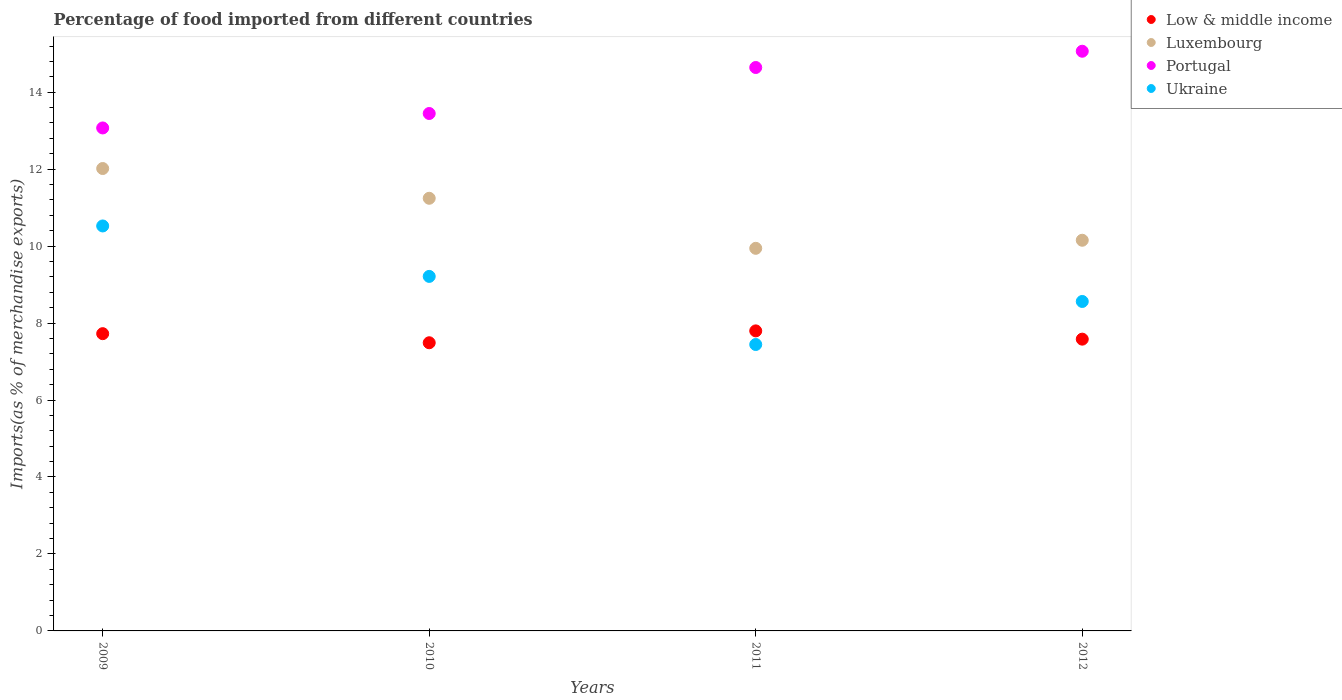How many different coloured dotlines are there?
Offer a very short reply. 4. Is the number of dotlines equal to the number of legend labels?
Ensure brevity in your answer.  Yes. What is the percentage of imports to different countries in Low & middle income in 2009?
Make the answer very short. 7.72. Across all years, what is the maximum percentage of imports to different countries in Ukraine?
Your answer should be very brief. 10.52. Across all years, what is the minimum percentage of imports to different countries in Low & middle income?
Give a very brief answer. 7.49. In which year was the percentage of imports to different countries in Ukraine maximum?
Your answer should be compact. 2009. In which year was the percentage of imports to different countries in Low & middle income minimum?
Make the answer very short. 2010. What is the total percentage of imports to different countries in Low & middle income in the graph?
Offer a very short reply. 30.59. What is the difference between the percentage of imports to different countries in Low & middle income in 2011 and that in 2012?
Keep it short and to the point. 0.21. What is the difference between the percentage of imports to different countries in Ukraine in 2009 and the percentage of imports to different countries in Portugal in 2012?
Provide a succinct answer. -4.54. What is the average percentage of imports to different countries in Ukraine per year?
Provide a short and direct response. 8.94. In the year 2011, what is the difference between the percentage of imports to different countries in Ukraine and percentage of imports to different countries in Portugal?
Offer a terse response. -7.2. In how many years, is the percentage of imports to different countries in Low & middle income greater than 14.4 %?
Your answer should be very brief. 0. What is the ratio of the percentage of imports to different countries in Luxembourg in 2010 to that in 2011?
Keep it short and to the point. 1.13. Is the percentage of imports to different countries in Ukraine in 2010 less than that in 2012?
Make the answer very short. No. Is the difference between the percentage of imports to different countries in Ukraine in 2009 and 2012 greater than the difference between the percentage of imports to different countries in Portugal in 2009 and 2012?
Provide a short and direct response. Yes. What is the difference between the highest and the second highest percentage of imports to different countries in Ukraine?
Your answer should be compact. 1.31. What is the difference between the highest and the lowest percentage of imports to different countries in Portugal?
Provide a succinct answer. 1.99. In how many years, is the percentage of imports to different countries in Portugal greater than the average percentage of imports to different countries in Portugal taken over all years?
Your answer should be very brief. 2. Is the sum of the percentage of imports to different countries in Ukraine in 2009 and 2011 greater than the maximum percentage of imports to different countries in Portugal across all years?
Offer a very short reply. Yes. Is it the case that in every year, the sum of the percentage of imports to different countries in Luxembourg and percentage of imports to different countries in Portugal  is greater than the sum of percentage of imports to different countries in Ukraine and percentage of imports to different countries in Low & middle income?
Your response must be concise. No. Is the percentage of imports to different countries in Low & middle income strictly less than the percentage of imports to different countries in Portugal over the years?
Your response must be concise. Yes. How many dotlines are there?
Offer a very short reply. 4. How many legend labels are there?
Provide a short and direct response. 4. What is the title of the graph?
Your answer should be compact. Percentage of food imported from different countries. Does "Belgium" appear as one of the legend labels in the graph?
Your response must be concise. No. What is the label or title of the X-axis?
Provide a succinct answer. Years. What is the label or title of the Y-axis?
Offer a very short reply. Imports(as % of merchandise exports). What is the Imports(as % of merchandise exports) of Low & middle income in 2009?
Provide a short and direct response. 7.72. What is the Imports(as % of merchandise exports) in Luxembourg in 2009?
Ensure brevity in your answer.  12.02. What is the Imports(as % of merchandise exports) of Portugal in 2009?
Offer a terse response. 13.07. What is the Imports(as % of merchandise exports) of Ukraine in 2009?
Ensure brevity in your answer.  10.52. What is the Imports(as % of merchandise exports) of Low & middle income in 2010?
Keep it short and to the point. 7.49. What is the Imports(as % of merchandise exports) of Luxembourg in 2010?
Offer a terse response. 11.24. What is the Imports(as % of merchandise exports) in Portugal in 2010?
Your answer should be compact. 13.45. What is the Imports(as % of merchandise exports) of Ukraine in 2010?
Your answer should be compact. 9.21. What is the Imports(as % of merchandise exports) of Low & middle income in 2011?
Your answer should be very brief. 7.8. What is the Imports(as % of merchandise exports) in Luxembourg in 2011?
Your answer should be very brief. 9.94. What is the Imports(as % of merchandise exports) of Portugal in 2011?
Give a very brief answer. 14.64. What is the Imports(as % of merchandise exports) in Ukraine in 2011?
Offer a very short reply. 7.44. What is the Imports(as % of merchandise exports) in Low & middle income in 2012?
Make the answer very short. 7.58. What is the Imports(as % of merchandise exports) of Luxembourg in 2012?
Your answer should be compact. 10.15. What is the Imports(as % of merchandise exports) in Portugal in 2012?
Your response must be concise. 15.06. What is the Imports(as % of merchandise exports) of Ukraine in 2012?
Offer a very short reply. 8.56. Across all years, what is the maximum Imports(as % of merchandise exports) of Low & middle income?
Your answer should be very brief. 7.8. Across all years, what is the maximum Imports(as % of merchandise exports) of Luxembourg?
Ensure brevity in your answer.  12.02. Across all years, what is the maximum Imports(as % of merchandise exports) in Portugal?
Your answer should be very brief. 15.06. Across all years, what is the maximum Imports(as % of merchandise exports) in Ukraine?
Ensure brevity in your answer.  10.52. Across all years, what is the minimum Imports(as % of merchandise exports) in Low & middle income?
Provide a succinct answer. 7.49. Across all years, what is the minimum Imports(as % of merchandise exports) of Luxembourg?
Provide a succinct answer. 9.94. Across all years, what is the minimum Imports(as % of merchandise exports) in Portugal?
Keep it short and to the point. 13.07. Across all years, what is the minimum Imports(as % of merchandise exports) of Ukraine?
Your answer should be very brief. 7.44. What is the total Imports(as % of merchandise exports) of Low & middle income in the graph?
Your answer should be very brief. 30.59. What is the total Imports(as % of merchandise exports) in Luxembourg in the graph?
Ensure brevity in your answer.  43.35. What is the total Imports(as % of merchandise exports) in Portugal in the graph?
Your response must be concise. 56.22. What is the total Imports(as % of merchandise exports) in Ukraine in the graph?
Your answer should be very brief. 35.74. What is the difference between the Imports(as % of merchandise exports) of Low & middle income in 2009 and that in 2010?
Provide a short and direct response. 0.24. What is the difference between the Imports(as % of merchandise exports) in Luxembourg in 2009 and that in 2010?
Keep it short and to the point. 0.77. What is the difference between the Imports(as % of merchandise exports) of Portugal in 2009 and that in 2010?
Keep it short and to the point. -0.38. What is the difference between the Imports(as % of merchandise exports) in Ukraine in 2009 and that in 2010?
Your answer should be very brief. 1.31. What is the difference between the Imports(as % of merchandise exports) in Low & middle income in 2009 and that in 2011?
Offer a very short reply. -0.07. What is the difference between the Imports(as % of merchandise exports) of Luxembourg in 2009 and that in 2011?
Make the answer very short. 2.07. What is the difference between the Imports(as % of merchandise exports) of Portugal in 2009 and that in 2011?
Make the answer very short. -1.57. What is the difference between the Imports(as % of merchandise exports) of Ukraine in 2009 and that in 2011?
Your answer should be compact. 3.08. What is the difference between the Imports(as % of merchandise exports) in Low & middle income in 2009 and that in 2012?
Your answer should be very brief. 0.14. What is the difference between the Imports(as % of merchandise exports) of Luxembourg in 2009 and that in 2012?
Provide a succinct answer. 1.86. What is the difference between the Imports(as % of merchandise exports) of Portugal in 2009 and that in 2012?
Your answer should be compact. -1.99. What is the difference between the Imports(as % of merchandise exports) in Ukraine in 2009 and that in 2012?
Your answer should be compact. 1.96. What is the difference between the Imports(as % of merchandise exports) of Low & middle income in 2010 and that in 2011?
Make the answer very short. -0.31. What is the difference between the Imports(as % of merchandise exports) of Luxembourg in 2010 and that in 2011?
Provide a succinct answer. 1.3. What is the difference between the Imports(as % of merchandise exports) in Portugal in 2010 and that in 2011?
Make the answer very short. -1.2. What is the difference between the Imports(as % of merchandise exports) of Ukraine in 2010 and that in 2011?
Your answer should be very brief. 1.77. What is the difference between the Imports(as % of merchandise exports) of Low & middle income in 2010 and that in 2012?
Your answer should be very brief. -0.09. What is the difference between the Imports(as % of merchandise exports) of Luxembourg in 2010 and that in 2012?
Keep it short and to the point. 1.09. What is the difference between the Imports(as % of merchandise exports) of Portugal in 2010 and that in 2012?
Keep it short and to the point. -1.62. What is the difference between the Imports(as % of merchandise exports) in Ukraine in 2010 and that in 2012?
Offer a very short reply. 0.65. What is the difference between the Imports(as % of merchandise exports) in Low & middle income in 2011 and that in 2012?
Provide a succinct answer. 0.21. What is the difference between the Imports(as % of merchandise exports) of Luxembourg in 2011 and that in 2012?
Your answer should be compact. -0.21. What is the difference between the Imports(as % of merchandise exports) of Portugal in 2011 and that in 2012?
Provide a short and direct response. -0.42. What is the difference between the Imports(as % of merchandise exports) in Ukraine in 2011 and that in 2012?
Your response must be concise. -1.12. What is the difference between the Imports(as % of merchandise exports) of Low & middle income in 2009 and the Imports(as % of merchandise exports) of Luxembourg in 2010?
Offer a very short reply. -3.52. What is the difference between the Imports(as % of merchandise exports) of Low & middle income in 2009 and the Imports(as % of merchandise exports) of Portugal in 2010?
Provide a short and direct response. -5.72. What is the difference between the Imports(as % of merchandise exports) of Low & middle income in 2009 and the Imports(as % of merchandise exports) of Ukraine in 2010?
Provide a succinct answer. -1.49. What is the difference between the Imports(as % of merchandise exports) in Luxembourg in 2009 and the Imports(as % of merchandise exports) in Portugal in 2010?
Give a very brief answer. -1.43. What is the difference between the Imports(as % of merchandise exports) of Luxembourg in 2009 and the Imports(as % of merchandise exports) of Ukraine in 2010?
Give a very brief answer. 2.8. What is the difference between the Imports(as % of merchandise exports) of Portugal in 2009 and the Imports(as % of merchandise exports) of Ukraine in 2010?
Your answer should be compact. 3.86. What is the difference between the Imports(as % of merchandise exports) in Low & middle income in 2009 and the Imports(as % of merchandise exports) in Luxembourg in 2011?
Give a very brief answer. -2.22. What is the difference between the Imports(as % of merchandise exports) in Low & middle income in 2009 and the Imports(as % of merchandise exports) in Portugal in 2011?
Make the answer very short. -6.92. What is the difference between the Imports(as % of merchandise exports) of Low & middle income in 2009 and the Imports(as % of merchandise exports) of Ukraine in 2011?
Provide a short and direct response. 0.28. What is the difference between the Imports(as % of merchandise exports) in Luxembourg in 2009 and the Imports(as % of merchandise exports) in Portugal in 2011?
Keep it short and to the point. -2.63. What is the difference between the Imports(as % of merchandise exports) of Luxembourg in 2009 and the Imports(as % of merchandise exports) of Ukraine in 2011?
Offer a very short reply. 4.57. What is the difference between the Imports(as % of merchandise exports) of Portugal in 2009 and the Imports(as % of merchandise exports) of Ukraine in 2011?
Your answer should be compact. 5.63. What is the difference between the Imports(as % of merchandise exports) in Low & middle income in 2009 and the Imports(as % of merchandise exports) in Luxembourg in 2012?
Ensure brevity in your answer.  -2.43. What is the difference between the Imports(as % of merchandise exports) in Low & middle income in 2009 and the Imports(as % of merchandise exports) in Portugal in 2012?
Keep it short and to the point. -7.34. What is the difference between the Imports(as % of merchandise exports) in Low & middle income in 2009 and the Imports(as % of merchandise exports) in Ukraine in 2012?
Offer a terse response. -0.84. What is the difference between the Imports(as % of merchandise exports) in Luxembourg in 2009 and the Imports(as % of merchandise exports) in Portugal in 2012?
Offer a very short reply. -3.05. What is the difference between the Imports(as % of merchandise exports) of Luxembourg in 2009 and the Imports(as % of merchandise exports) of Ukraine in 2012?
Your response must be concise. 3.45. What is the difference between the Imports(as % of merchandise exports) in Portugal in 2009 and the Imports(as % of merchandise exports) in Ukraine in 2012?
Keep it short and to the point. 4.51. What is the difference between the Imports(as % of merchandise exports) in Low & middle income in 2010 and the Imports(as % of merchandise exports) in Luxembourg in 2011?
Offer a terse response. -2.45. What is the difference between the Imports(as % of merchandise exports) in Low & middle income in 2010 and the Imports(as % of merchandise exports) in Portugal in 2011?
Provide a succinct answer. -7.15. What is the difference between the Imports(as % of merchandise exports) of Low & middle income in 2010 and the Imports(as % of merchandise exports) of Ukraine in 2011?
Give a very brief answer. 0.05. What is the difference between the Imports(as % of merchandise exports) of Luxembourg in 2010 and the Imports(as % of merchandise exports) of Portugal in 2011?
Keep it short and to the point. -3.4. What is the difference between the Imports(as % of merchandise exports) of Luxembourg in 2010 and the Imports(as % of merchandise exports) of Ukraine in 2011?
Provide a succinct answer. 3.8. What is the difference between the Imports(as % of merchandise exports) in Portugal in 2010 and the Imports(as % of merchandise exports) in Ukraine in 2011?
Keep it short and to the point. 6. What is the difference between the Imports(as % of merchandise exports) in Low & middle income in 2010 and the Imports(as % of merchandise exports) in Luxembourg in 2012?
Ensure brevity in your answer.  -2.66. What is the difference between the Imports(as % of merchandise exports) of Low & middle income in 2010 and the Imports(as % of merchandise exports) of Portugal in 2012?
Offer a very short reply. -7.58. What is the difference between the Imports(as % of merchandise exports) in Low & middle income in 2010 and the Imports(as % of merchandise exports) in Ukraine in 2012?
Give a very brief answer. -1.07. What is the difference between the Imports(as % of merchandise exports) in Luxembourg in 2010 and the Imports(as % of merchandise exports) in Portugal in 2012?
Your answer should be compact. -3.82. What is the difference between the Imports(as % of merchandise exports) of Luxembourg in 2010 and the Imports(as % of merchandise exports) of Ukraine in 2012?
Your answer should be compact. 2.68. What is the difference between the Imports(as % of merchandise exports) of Portugal in 2010 and the Imports(as % of merchandise exports) of Ukraine in 2012?
Provide a short and direct response. 4.88. What is the difference between the Imports(as % of merchandise exports) in Low & middle income in 2011 and the Imports(as % of merchandise exports) in Luxembourg in 2012?
Provide a succinct answer. -2.36. What is the difference between the Imports(as % of merchandise exports) in Low & middle income in 2011 and the Imports(as % of merchandise exports) in Portugal in 2012?
Provide a short and direct response. -7.27. What is the difference between the Imports(as % of merchandise exports) of Low & middle income in 2011 and the Imports(as % of merchandise exports) of Ukraine in 2012?
Provide a succinct answer. -0.76. What is the difference between the Imports(as % of merchandise exports) of Luxembourg in 2011 and the Imports(as % of merchandise exports) of Portugal in 2012?
Your answer should be compact. -5.12. What is the difference between the Imports(as % of merchandise exports) of Luxembourg in 2011 and the Imports(as % of merchandise exports) of Ukraine in 2012?
Keep it short and to the point. 1.38. What is the difference between the Imports(as % of merchandise exports) of Portugal in 2011 and the Imports(as % of merchandise exports) of Ukraine in 2012?
Keep it short and to the point. 6.08. What is the average Imports(as % of merchandise exports) of Low & middle income per year?
Ensure brevity in your answer.  7.65. What is the average Imports(as % of merchandise exports) of Luxembourg per year?
Provide a succinct answer. 10.84. What is the average Imports(as % of merchandise exports) of Portugal per year?
Keep it short and to the point. 14.06. What is the average Imports(as % of merchandise exports) in Ukraine per year?
Offer a terse response. 8.94. In the year 2009, what is the difference between the Imports(as % of merchandise exports) in Low & middle income and Imports(as % of merchandise exports) in Luxembourg?
Make the answer very short. -4.29. In the year 2009, what is the difference between the Imports(as % of merchandise exports) in Low & middle income and Imports(as % of merchandise exports) in Portugal?
Make the answer very short. -5.35. In the year 2009, what is the difference between the Imports(as % of merchandise exports) in Low & middle income and Imports(as % of merchandise exports) in Ukraine?
Offer a very short reply. -2.8. In the year 2009, what is the difference between the Imports(as % of merchandise exports) in Luxembourg and Imports(as % of merchandise exports) in Portugal?
Your answer should be very brief. -1.05. In the year 2009, what is the difference between the Imports(as % of merchandise exports) in Luxembourg and Imports(as % of merchandise exports) in Ukraine?
Offer a terse response. 1.49. In the year 2009, what is the difference between the Imports(as % of merchandise exports) in Portugal and Imports(as % of merchandise exports) in Ukraine?
Offer a terse response. 2.55. In the year 2010, what is the difference between the Imports(as % of merchandise exports) of Low & middle income and Imports(as % of merchandise exports) of Luxembourg?
Keep it short and to the point. -3.75. In the year 2010, what is the difference between the Imports(as % of merchandise exports) in Low & middle income and Imports(as % of merchandise exports) in Portugal?
Offer a terse response. -5.96. In the year 2010, what is the difference between the Imports(as % of merchandise exports) in Low & middle income and Imports(as % of merchandise exports) in Ukraine?
Offer a very short reply. -1.72. In the year 2010, what is the difference between the Imports(as % of merchandise exports) in Luxembourg and Imports(as % of merchandise exports) in Portugal?
Offer a very short reply. -2.2. In the year 2010, what is the difference between the Imports(as % of merchandise exports) in Luxembourg and Imports(as % of merchandise exports) in Ukraine?
Offer a very short reply. 2.03. In the year 2010, what is the difference between the Imports(as % of merchandise exports) of Portugal and Imports(as % of merchandise exports) of Ukraine?
Your response must be concise. 4.23. In the year 2011, what is the difference between the Imports(as % of merchandise exports) of Low & middle income and Imports(as % of merchandise exports) of Luxembourg?
Your response must be concise. -2.15. In the year 2011, what is the difference between the Imports(as % of merchandise exports) of Low & middle income and Imports(as % of merchandise exports) of Portugal?
Your response must be concise. -6.84. In the year 2011, what is the difference between the Imports(as % of merchandise exports) of Low & middle income and Imports(as % of merchandise exports) of Ukraine?
Your answer should be very brief. 0.35. In the year 2011, what is the difference between the Imports(as % of merchandise exports) of Luxembourg and Imports(as % of merchandise exports) of Portugal?
Give a very brief answer. -4.7. In the year 2011, what is the difference between the Imports(as % of merchandise exports) in Luxembourg and Imports(as % of merchandise exports) in Ukraine?
Ensure brevity in your answer.  2.5. In the year 2011, what is the difference between the Imports(as % of merchandise exports) in Portugal and Imports(as % of merchandise exports) in Ukraine?
Offer a very short reply. 7.2. In the year 2012, what is the difference between the Imports(as % of merchandise exports) in Low & middle income and Imports(as % of merchandise exports) in Luxembourg?
Offer a very short reply. -2.57. In the year 2012, what is the difference between the Imports(as % of merchandise exports) of Low & middle income and Imports(as % of merchandise exports) of Portugal?
Ensure brevity in your answer.  -7.48. In the year 2012, what is the difference between the Imports(as % of merchandise exports) in Low & middle income and Imports(as % of merchandise exports) in Ukraine?
Offer a terse response. -0.98. In the year 2012, what is the difference between the Imports(as % of merchandise exports) of Luxembourg and Imports(as % of merchandise exports) of Portugal?
Offer a terse response. -4.91. In the year 2012, what is the difference between the Imports(as % of merchandise exports) in Luxembourg and Imports(as % of merchandise exports) in Ukraine?
Provide a short and direct response. 1.59. In the year 2012, what is the difference between the Imports(as % of merchandise exports) in Portugal and Imports(as % of merchandise exports) in Ukraine?
Offer a terse response. 6.5. What is the ratio of the Imports(as % of merchandise exports) in Low & middle income in 2009 to that in 2010?
Offer a very short reply. 1.03. What is the ratio of the Imports(as % of merchandise exports) of Luxembourg in 2009 to that in 2010?
Offer a terse response. 1.07. What is the ratio of the Imports(as % of merchandise exports) in Portugal in 2009 to that in 2010?
Offer a very short reply. 0.97. What is the ratio of the Imports(as % of merchandise exports) of Ukraine in 2009 to that in 2010?
Offer a very short reply. 1.14. What is the ratio of the Imports(as % of merchandise exports) of Low & middle income in 2009 to that in 2011?
Keep it short and to the point. 0.99. What is the ratio of the Imports(as % of merchandise exports) of Luxembourg in 2009 to that in 2011?
Your response must be concise. 1.21. What is the ratio of the Imports(as % of merchandise exports) in Portugal in 2009 to that in 2011?
Provide a succinct answer. 0.89. What is the ratio of the Imports(as % of merchandise exports) of Ukraine in 2009 to that in 2011?
Your answer should be compact. 1.41. What is the ratio of the Imports(as % of merchandise exports) of Low & middle income in 2009 to that in 2012?
Your response must be concise. 1.02. What is the ratio of the Imports(as % of merchandise exports) in Luxembourg in 2009 to that in 2012?
Keep it short and to the point. 1.18. What is the ratio of the Imports(as % of merchandise exports) in Portugal in 2009 to that in 2012?
Give a very brief answer. 0.87. What is the ratio of the Imports(as % of merchandise exports) of Ukraine in 2009 to that in 2012?
Provide a succinct answer. 1.23. What is the ratio of the Imports(as % of merchandise exports) of Low & middle income in 2010 to that in 2011?
Your answer should be compact. 0.96. What is the ratio of the Imports(as % of merchandise exports) in Luxembourg in 2010 to that in 2011?
Offer a very short reply. 1.13. What is the ratio of the Imports(as % of merchandise exports) of Portugal in 2010 to that in 2011?
Offer a very short reply. 0.92. What is the ratio of the Imports(as % of merchandise exports) of Ukraine in 2010 to that in 2011?
Provide a succinct answer. 1.24. What is the ratio of the Imports(as % of merchandise exports) in Low & middle income in 2010 to that in 2012?
Your answer should be very brief. 0.99. What is the ratio of the Imports(as % of merchandise exports) in Luxembourg in 2010 to that in 2012?
Your response must be concise. 1.11. What is the ratio of the Imports(as % of merchandise exports) in Portugal in 2010 to that in 2012?
Make the answer very short. 0.89. What is the ratio of the Imports(as % of merchandise exports) in Ukraine in 2010 to that in 2012?
Provide a succinct answer. 1.08. What is the ratio of the Imports(as % of merchandise exports) in Low & middle income in 2011 to that in 2012?
Your answer should be compact. 1.03. What is the ratio of the Imports(as % of merchandise exports) in Luxembourg in 2011 to that in 2012?
Offer a terse response. 0.98. What is the ratio of the Imports(as % of merchandise exports) of Portugal in 2011 to that in 2012?
Provide a short and direct response. 0.97. What is the ratio of the Imports(as % of merchandise exports) in Ukraine in 2011 to that in 2012?
Ensure brevity in your answer.  0.87. What is the difference between the highest and the second highest Imports(as % of merchandise exports) of Low & middle income?
Ensure brevity in your answer.  0.07. What is the difference between the highest and the second highest Imports(as % of merchandise exports) in Luxembourg?
Offer a very short reply. 0.77. What is the difference between the highest and the second highest Imports(as % of merchandise exports) of Portugal?
Your answer should be very brief. 0.42. What is the difference between the highest and the second highest Imports(as % of merchandise exports) of Ukraine?
Your response must be concise. 1.31. What is the difference between the highest and the lowest Imports(as % of merchandise exports) of Low & middle income?
Provide a succinct answer. 0.31. What is the difference between the highest and the lowest Imports(as % of merchandise exports) in Luxembourg?
Your response must be concise. 2.07. What is the difference between the highest and the lowest Imports(as % of merchandise exports) in Portugal?
Give a very brief answer. 1.99. What is the difference between the highest and the lowest Imports(as % of merchandise exports) of Ukraine?
Your response must be concise. 3.08. 